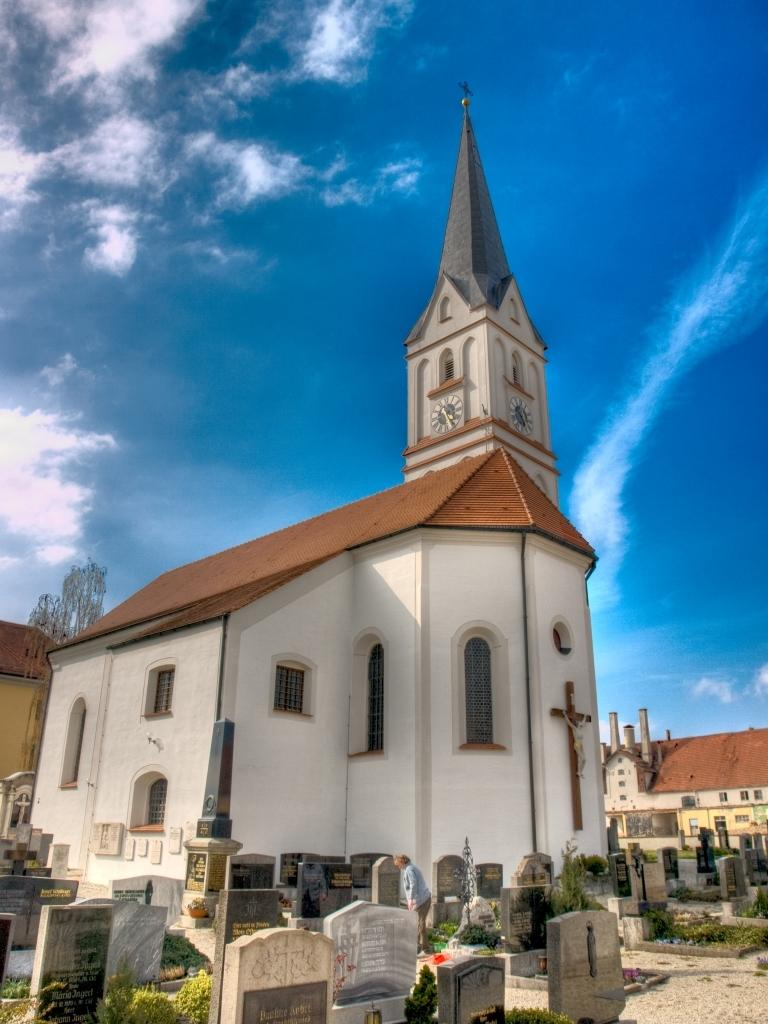What type of structures can be seen in the image? There are tombstones in the image. What else is present in the image besides the tombstones? There are plants in the image. What can be seen in the background of the image? There are buildings and the sky visible in the background of the image. What type of learning system is being used by the plants in the image? There is no learning system present in the image; the plants are not engaged in any learning activity. 